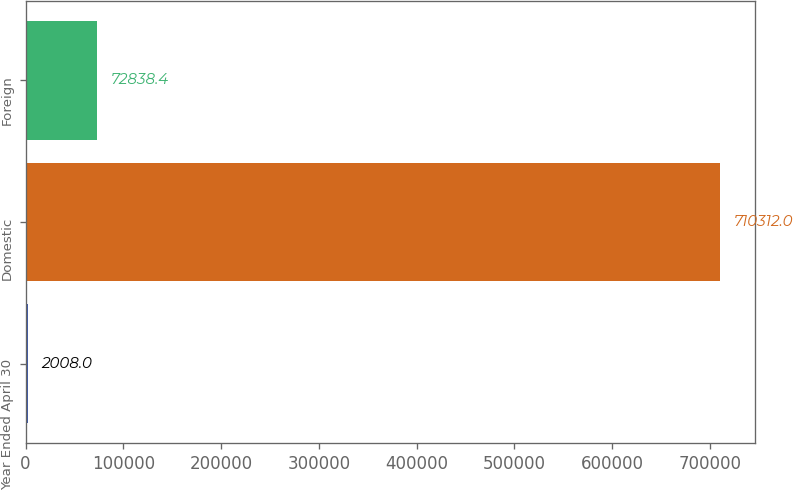Convert chart. <chart><loc_0><loc_0><loc_500><loc_500><bar_chart><fcel>Year Ended April 30<fcel>Domestic<fcel>Foreign<nl><fcel>2008<fcel>710312<fcel>72838.4<nl></chart> 